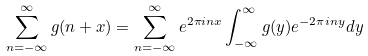Convert formula to latex. <formula><loc_0><loc_0><loc_500><loc_500>\sum _ { n = - \infty } ^ { \infty } g ( n + x ) = \sum _ { n = - \infty } ^ { \infty } e ^ { 2 \pi i n x } \int _ { - \infty } ^ { \infty } g ( y ) e ^ { - 2 \pi i n y } d y</formula> 